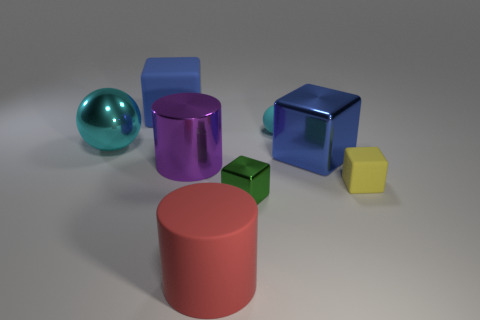Add 1 big rubber cubes. How many objects exist? 9 Subtract all green blocks. How many blocks are left? 3 Subtract all spheres. How many objects are left? 6 Subtract all red cylinders. Subtract all purple blocks. How many cylinders are left? 1 Subtract all yellow blocks. How many red cylinders are left? 1 Subtract all large blue cubes. Subtract all big blue rubber blocks. How many objects are left? 5 Add 4 big cyan shiny objects. How many big cyan shiny objects are left? 5 Add 7 big rubber cylinders. How many big rubber cylinders exist? 8 Subtract 1 blue cubes. How many objects are left? 7 Subtract 1 balls. How many balls are left? 1 